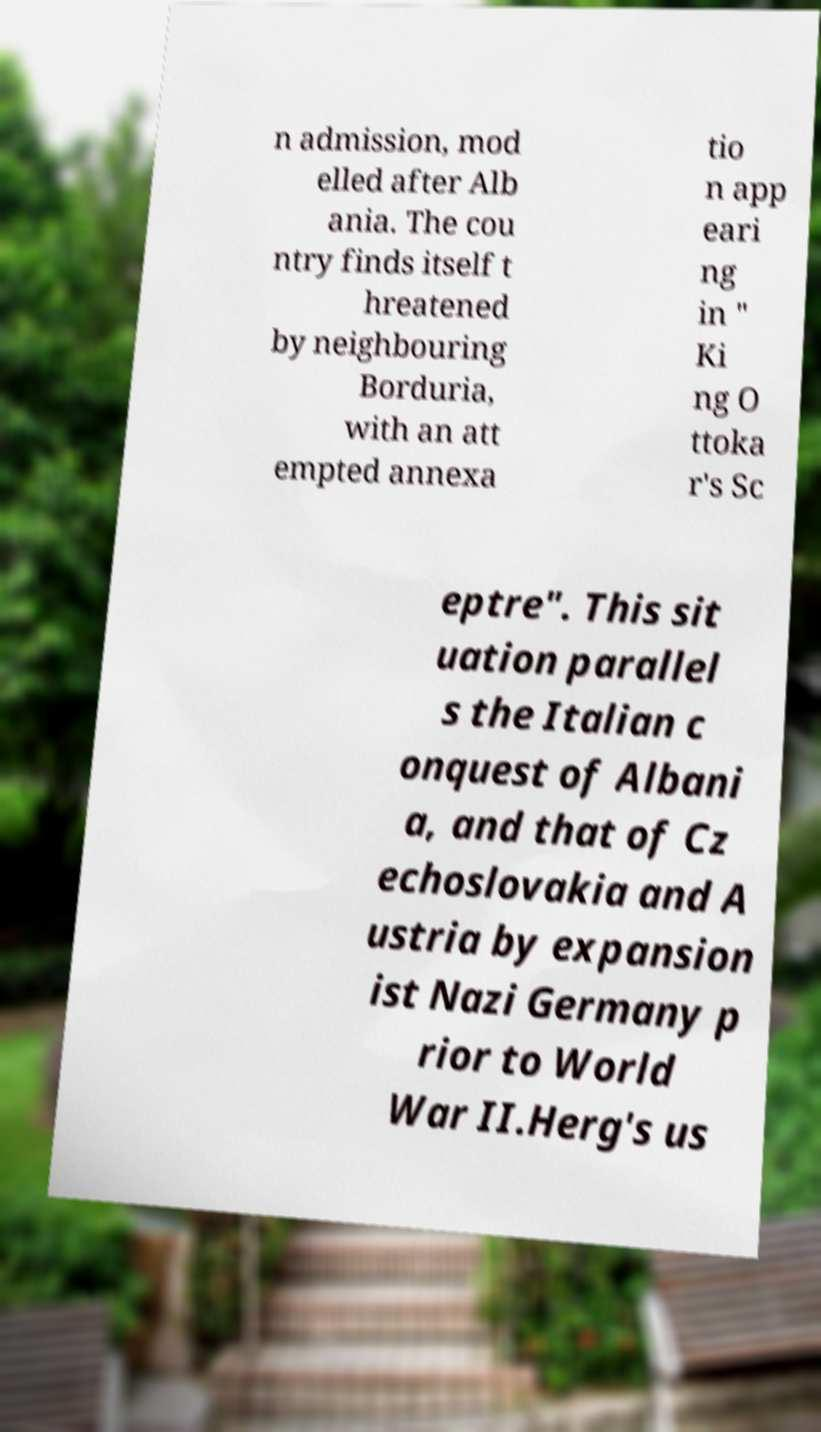For documentation purposes, I need the text within this image transcribed. Could you provide that? n admission, mod elled after Alb ania. The cou ntry finds itself t hreatened by neighbouring Borduria, with an att empted annexa tio n app eari ng in " Ki ng O ttoka r's Sc eptre". This sit uation parallel s the Italian c onquest of Albani a, and that of Cz echoslovakia and A ustria by expansion ist Nazi Germany p rior to World War II.Herg's us 